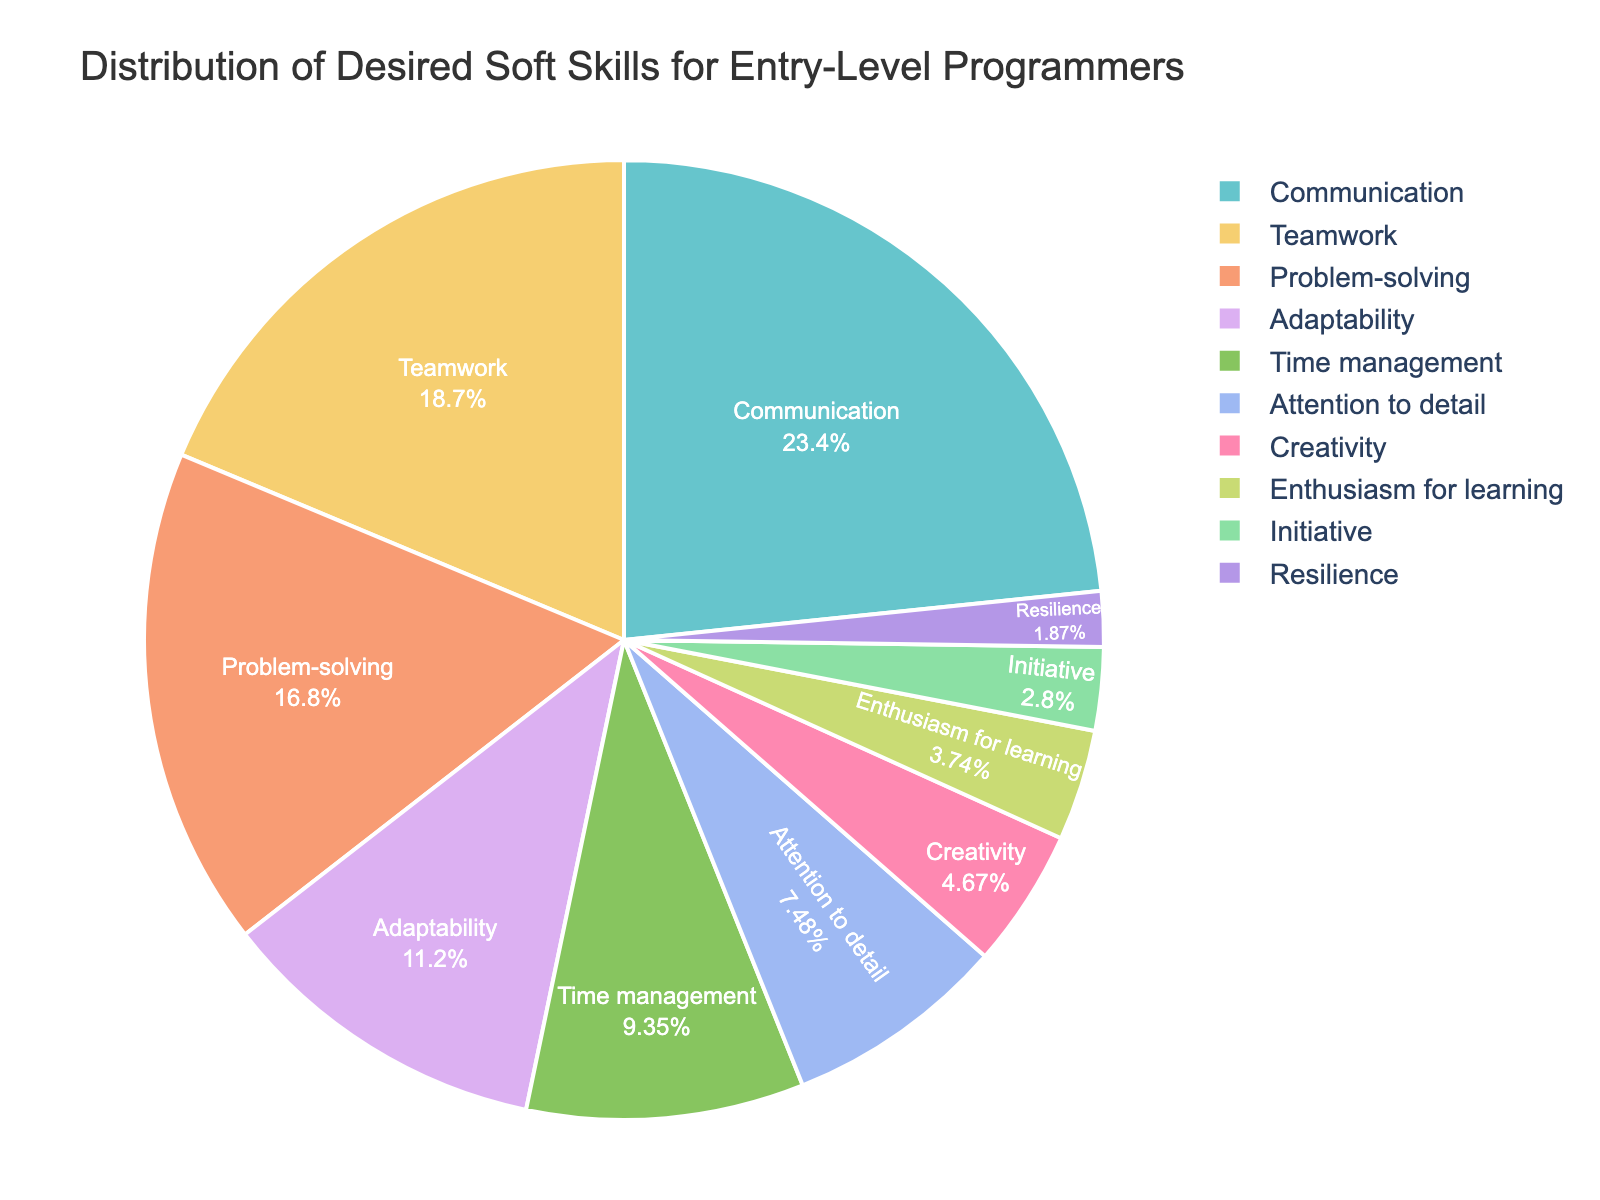Which soft skill has the highest percentage? The highest percentage is associated with the soft skill that occupies the largest part of the pie chart. In this case, the soft skill "Communication" has the highest percentage.
Answer: Communication Which two soft skills together account for more than 40% of the desired skills? To determine this, sum the percentages of the two largest segments. "Communication" is 25% and "Teamwork" is 20%. Their sum is 45%, which is more than 40%.
Answer: Communication and Teamwork What is the difference in percentage between Problem-solving and Adaptability? To find this, subtract the percentage of Adaptability from that of Problem-solving: 18% - 12% = 6%.
Answer: 6% Which soft skills have less than 5% representation? Look at the segments of the pie chart that are visually smaller than the others, specifically those less than 5%. These are "Enthusiasm for learning" (4%), "Initiative" (3%), and "Resilience" (2%).
Answer: Enthusiasm for learning, Initiative, Resilience What is the combined percentage of all skills related to project completion (Problem-solving, Time management, and Attention to detail)? Sum the percentages of these skills: 18% (Problem-solving) + 10% (Time management) + 8% (Attention to detail) = 36%.
Answer: 36% Which skill is represented by the smallest segment on the pie chart? Identify the smallest segment of the pie chart, which corresponds to the 2% value. This smallest segment represents "Resilience."
Answer: Resilience Which skill has the second-highest percentage after Communication? The second largest section after Communication (25%) is "Teamwork," which represents 20%.
Answer: Teamwork Are there more skills represented with percentages above or below 10%? Count the number of segments above and below 10%. Skills above 10%: 3 (Communication, Teamwork, Problem-solving). Skills below 10%: 7 (Adaptability, Time management, Attention to detail, Creativity, Enthusiasm for learning, Initiative, Resilience).
Answer: Below 10% What proportion of the chart is made up by Adaptability and Time management combined? Sum the percentages of Adaptability and Time management: 12% + 10% = 22%.
Answer: 22% Between Creativity and Enthusiasm for learning, which has a higher percentage? Compare the size of the segments representing Creativity and Enthusiasm for learning. Creativity is 5%, and Enthusiasm for learning is 4%. Therefore, Creativity has a higher percentage.
Answer: Creativity 